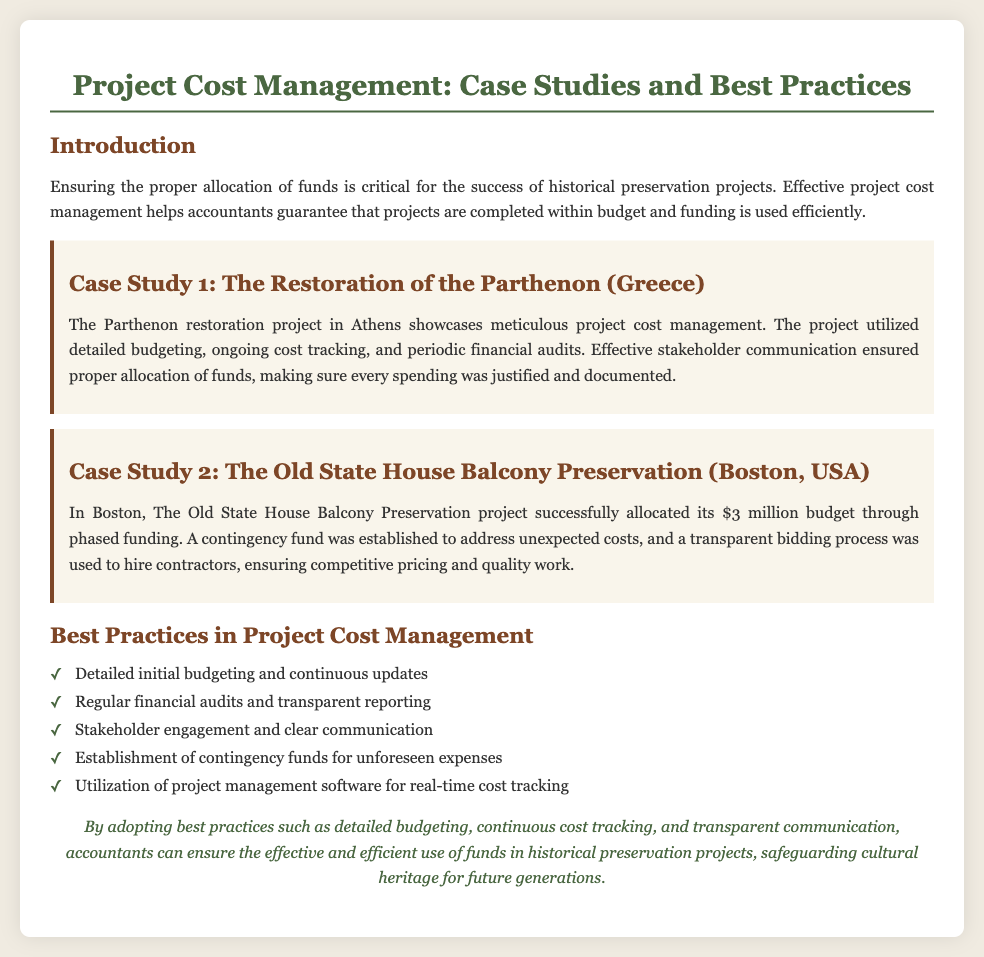What is the title of the presentation? The title of the presentation is the main heading of the document, which introduces the topic.
Answer: Project Cost Management: Case Studies and Best Practices How many case studies are presented? The number of case studies is determined by counting the distinct cases provided in the document.
Answer: 2 What is the budget for The Old State House Balcony Preservation project? The budget is explicitly stated in the case study description for The Old State House.
Answer: $3 million Which case study highlights stakeholder communication? The specific case mentions stakeholder communication as a key aspect of project cost management.
Answer: The Restoration of the Parthenon (Greece) What is one best practice in project cost management? A specific example of a best practice is listed in the document under the best practices section.
Answer: Detailed initial budgeting and continuous updates What type of funding was established for unexpected costs? The document mentions a specific mechanism that was put in place to address unforeseen financial issues.
Answer: Contingency fund In what city is The Old State House located? The city is mentioned in the title of the case study associated with the project.
Answer: Boston What is the focus of the conclusion section? The conclusion summarizes the key points related to the document's topic and its importance.
Answer: Effective and efficient use of funds in historical preservation projects 